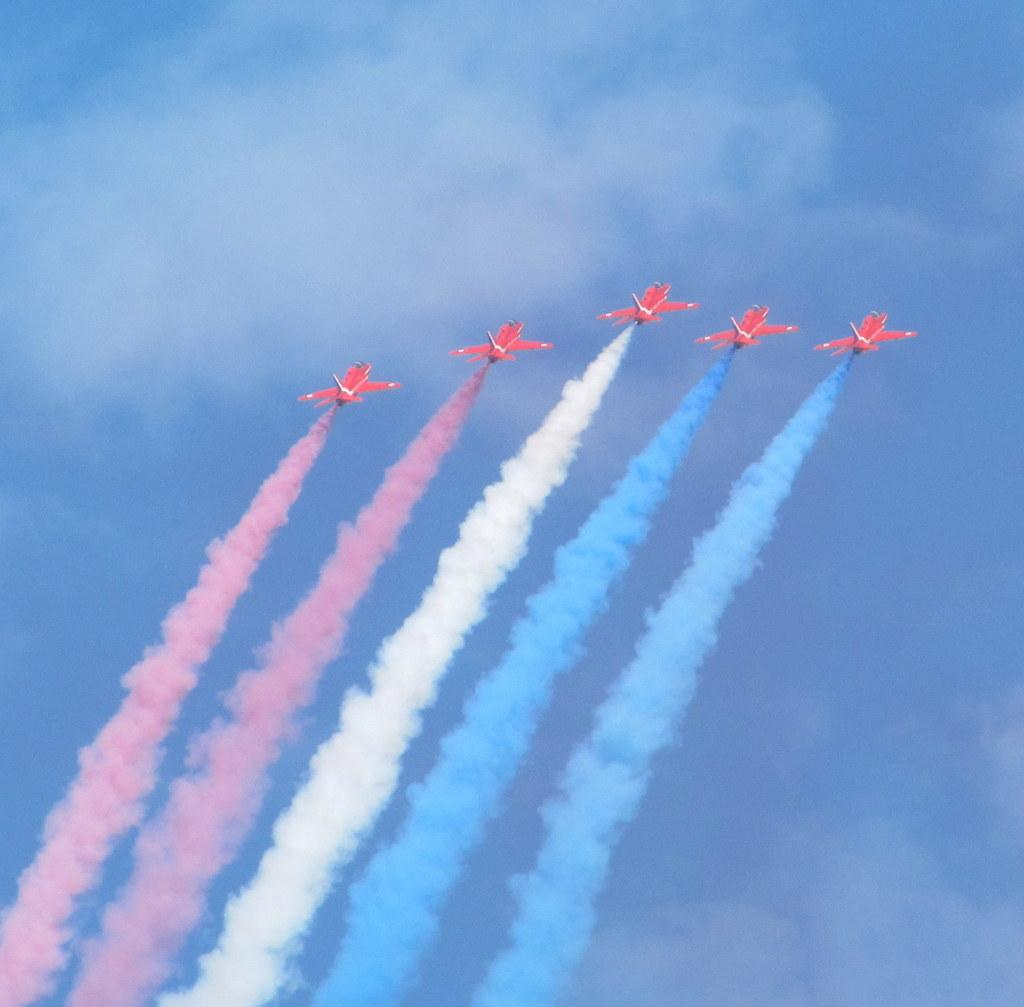How many aircrafts are visible in the image? There are five aircrafts in the image. What can be seen coming from the aircrafts? There is smoke in red, white, and blue colors coming from the aircrafts. What is the background of the image? The background of the image is the sky. What colors are visible in the sky? The sky is blue and white in color. What type of clam is being used as a propeller for one of the aircrafts in the image? There are no clams present in the image, and the aircrafts do not have clams as propellers. 